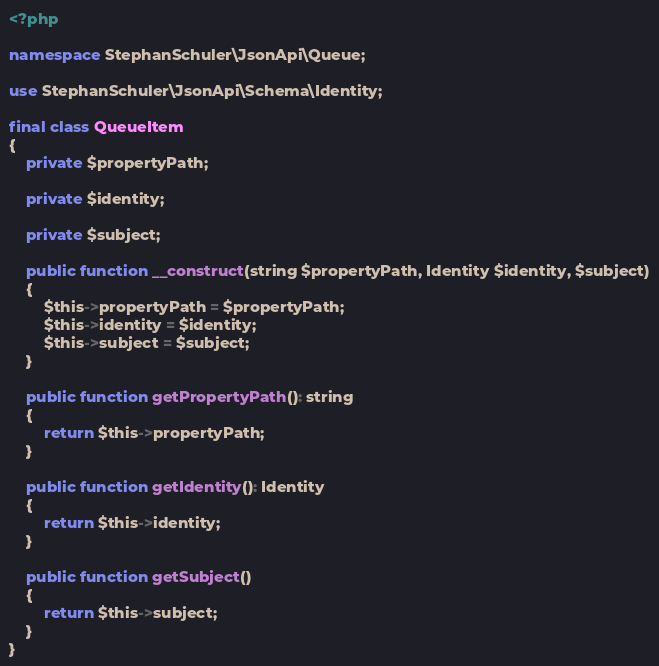<code> <loc_0><loc_0><loc_500><loc_500><_PHP_><?php

namespace StephanSchuler\JsonApi\Queue;

use StephanSchuler\JsonApi\Schema\Identity;

final class QueueItem
{
    private $propertyPath;

    private $identity;

    private $subject;

    public function __construct(string $propertyPath, Identity $identity, $subject)
    {
        $this->propertyPath = $propertyPath;
        $this->identity = $identity;
        $this->subject = $subject;
    }

    public function getPropertyPath(): string
    {
        return $this->propertyPath;
    }

    public function getIdentity(): Identity
    {
        return $this->identity;
    }

    public function getSubject()
    {
        return $this->subject;
    }
}</code> 